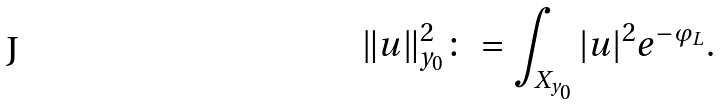<formula> <loc_0><loc_0><loc_500><loc_500>\| u \| _ { y _ { 0 } } ^ { 2 } \colon = \int _ { X _ { y _ { 0 } } } | u | ^ { 2 } e ^ { - \varphi _ { L } } .</formula> 